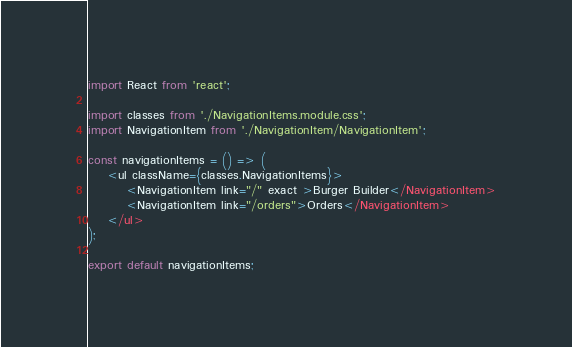Convert code to text. <code><loc_0><loc_0><loc_500><loc_500><_JavaScript_>import React from 'react';

import classes from './NavigationItems.module.css';
import NavigationItem from './NavigationItem/NavigationItem';

const navigationItems = () => (
    <ul className={classes.NavigationItems}>
        <NavigationItem link="/" exact >Burger Builder</NavigationItem>
        <NavigationItem link="/orders">Orders</NavigationItem>
    </ul>
);

export default navigationItems;</code> 